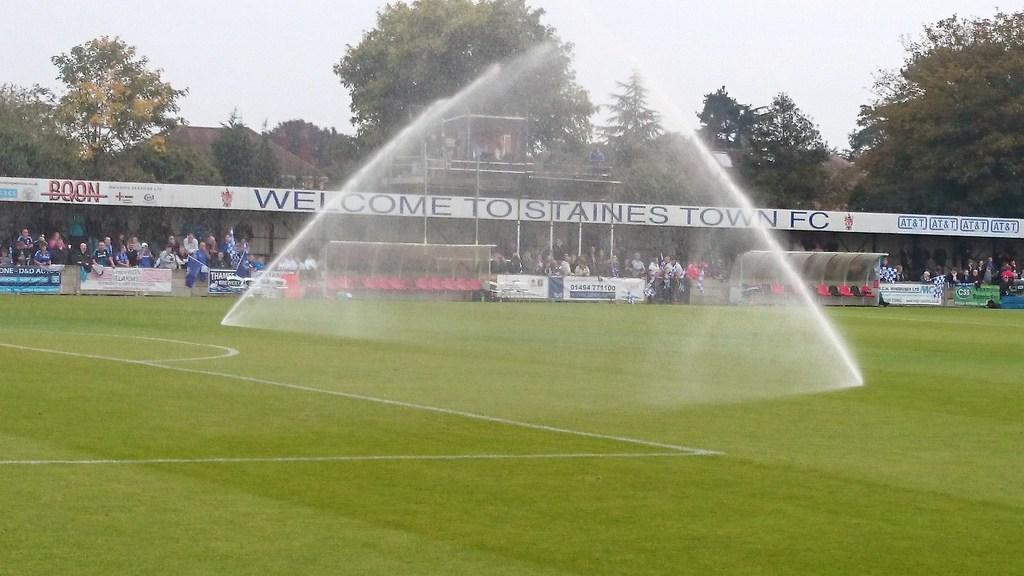<image>
Relay a brief, clear account of the picture shown. the word welcome is on the sign that is in the outfield 